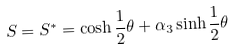<formula> <loc_0><loc_0><loc_500><loc_500>S = S ^ { * } = \cosh \frac { 1 } { 2 } \theta + \alpha _ { 3 } \sinh \frac { 1 } { 2 } \theta</formula> 